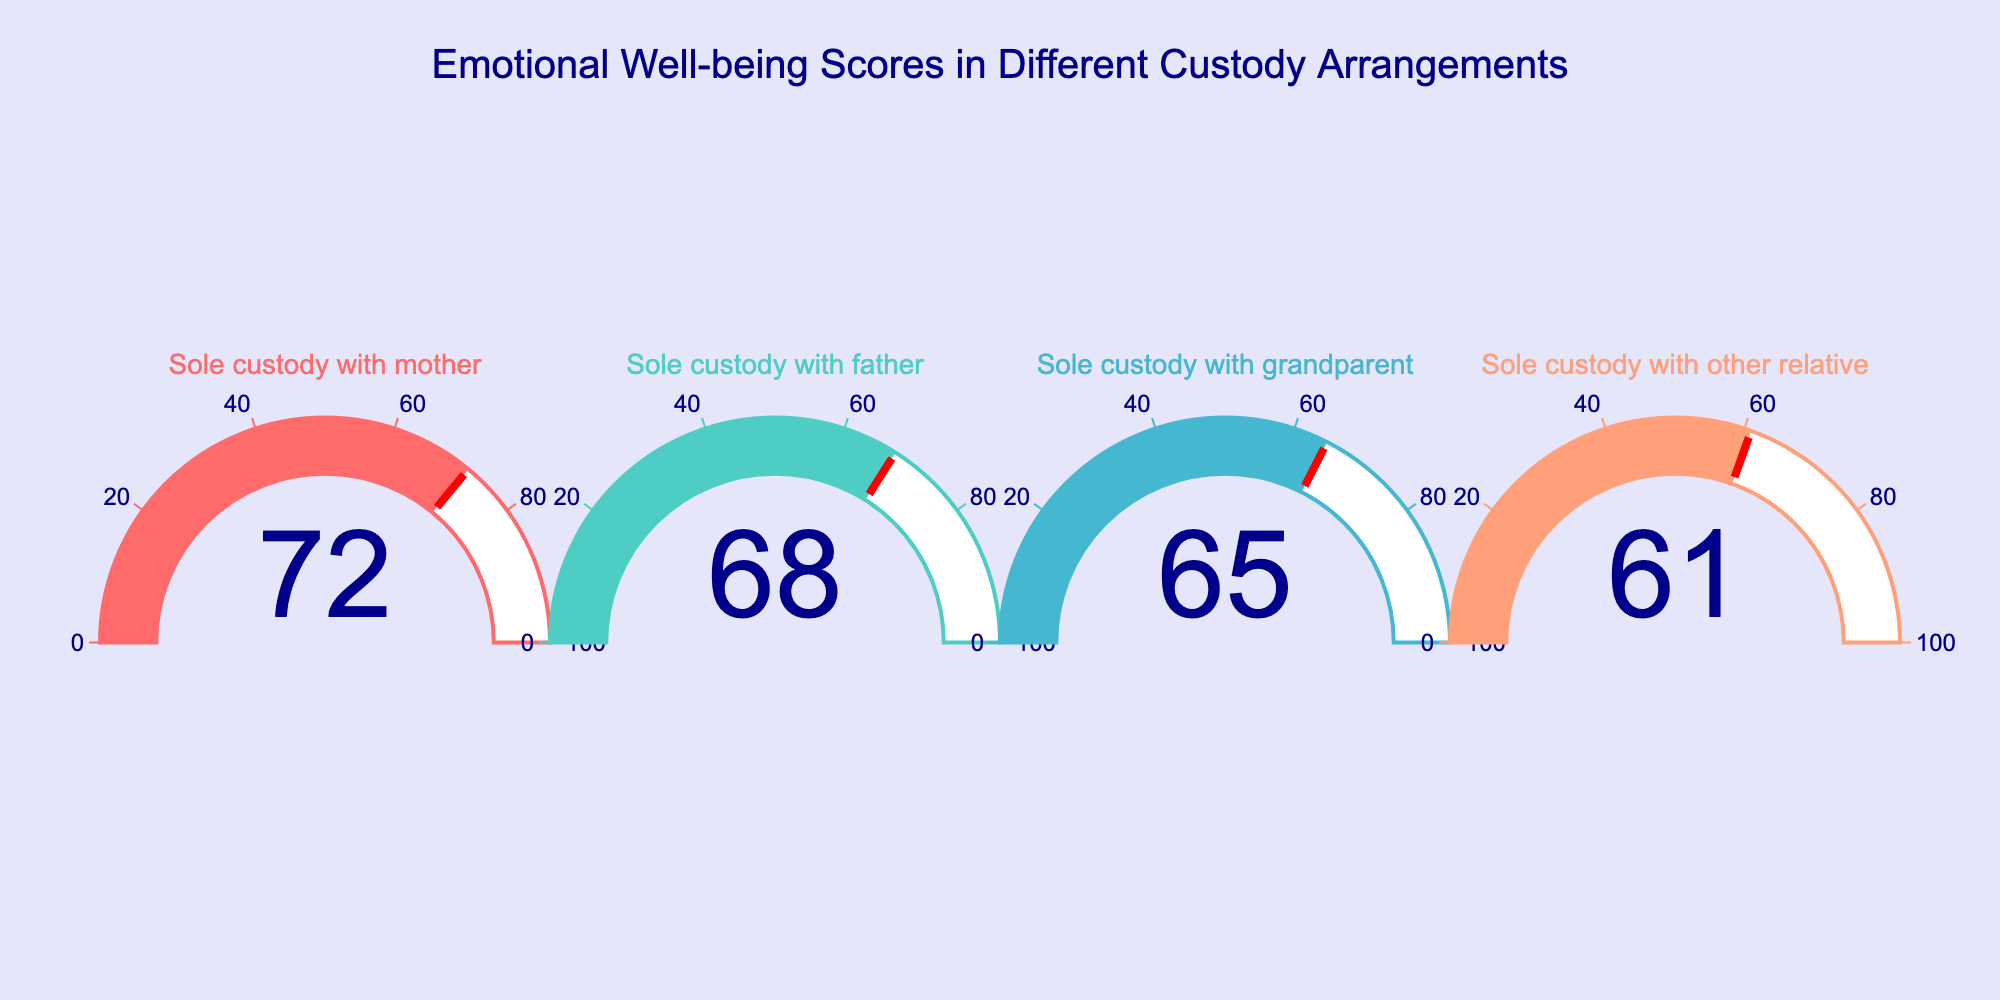What's the emotional well-being score for children in sole custody with mother? The gauge chart directly shows the score for children in sole custody with mother.
Answer: 72 Which custody arrangement has the lowest emotional well-being score? By comparing the values on the gauge charts, we can see that the "sole custody with other relative" arrangement has the lowest score.
Answer: Sole custody with other relative What is the difference between the emotional well-being scores of children in sole custody with mother and sole custody with father? The score for sole custody with mother is 72 and for sole custody with father is 68. The difference is 72 - 68 = 4.
Answer: 4 What's the average emotional well-being score across all the depicted custody arrangements? Sum all the scores and divide by the number of custody arrangements. (72 + 68 + 65 + 61) / 4 = 266 / 4 = 66.5.
Answer: 66.5 Which custody arrangement has a score closest to the average score of all the arrangements? The average score is 66.5. Comparing it to each custody arrangement, the "sole custody with grandparent" with a score of 65 is closest to 66.5.
Answer: Sole custody with grandparent How much lower is the emotional well-being score for children in sole custody with other relatives compared to those in sole custody with mother? The score for sole custody with other relatives is 61, and for sole custody with mother, it is 72. The difference is 72 - 61 = 11.
Answer: 11 Rank the custody arrangements from highest to lowest based on emotional well-being scores. List the scores in descending order: 72 (Mother), 68 (Father), 65 (Grandparent), 61 (Other relative).
Answer: Sole custody with mother > Sole custody with father > Sole custody with grandparent > Sole custody with other relative How many custody arrangements are displayed in the gauge chart? The number of distinct gauge indicators corresponds to the number of custody arrangements.
Answer: 4 What is the emotional well-being score range depicted in the gauge chart? The gauge chart shows scores ranging from the lowest (61) to the highest (72).
Answer: 61 to 72 